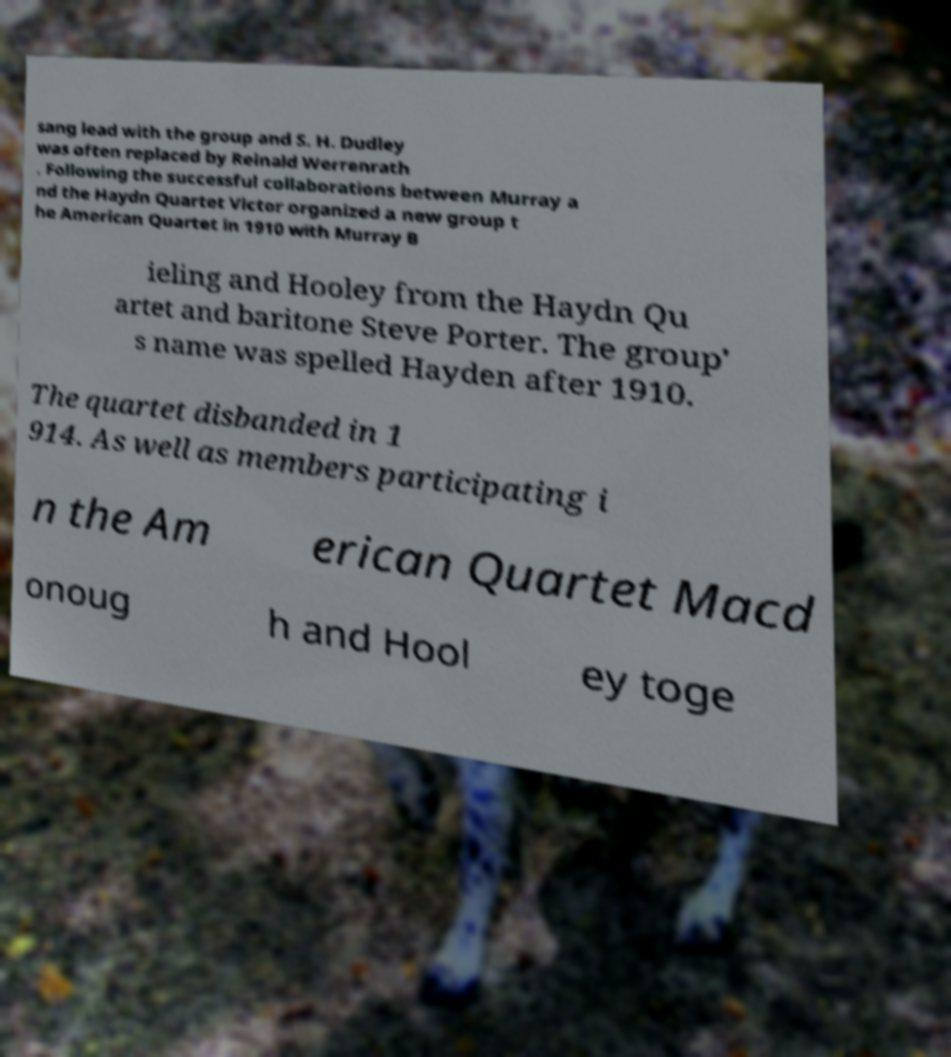There's text embedded in this image that I need extracted. Can you transcribe it verbatim? sang lead with the group and S. H. Dudley was often replaced by Reinald Werrenrath . Following the successful collaborations between Murray a nd the Haydn Quartet Victor organized a new group t he American Quartet in 1910 with Murray B ieling and Hooley from the Haydn Qu artet and baritone Steve Porter. The group' s name was spelled Hayden after 1910. The quartet disbanded in 1 914. As well as members participating i n the Am erican Quartet Macd onoug h and Hool ey toge 